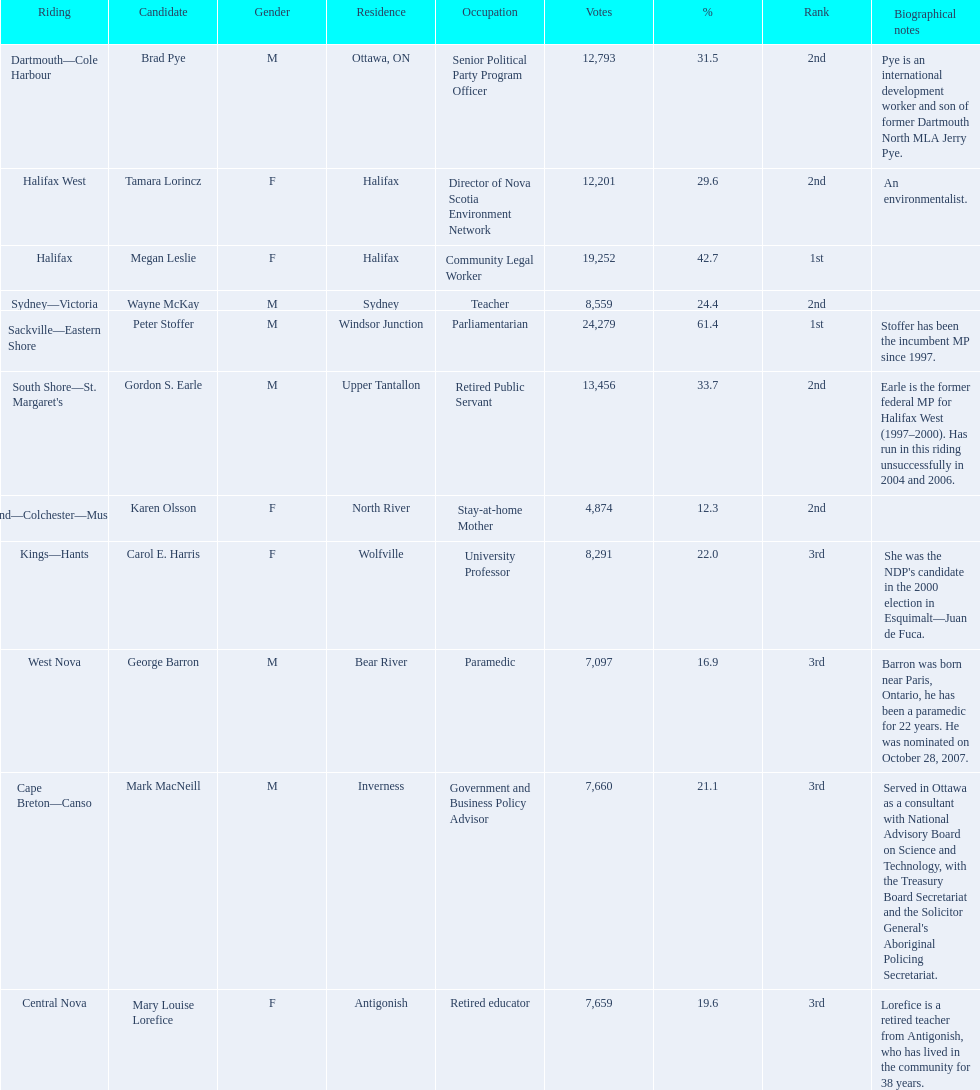What new democratic party candidates ran in the 2008 canadian federal election? Mark MacNeill, Mary Louise Lorefice, Karen Olsson, Brad Pye, Megan Leslie, Tamara Lorincz, Carol E. Harris, Peter Stoffer, Gordon S. Earle, Wayne McKay, George Barron. Of these candidates, which are female? Mary Louise Lorefice, Karen Olsson, Megan Leslie, Tamara Lorincz, Carol E. Harris. Which of these candidates resides in halifax? Megan Leslie, Tamara Lorincz. Of the remaining two, which was ranked 1st? Megan Leslie. How many votes did she get? 19,252. 